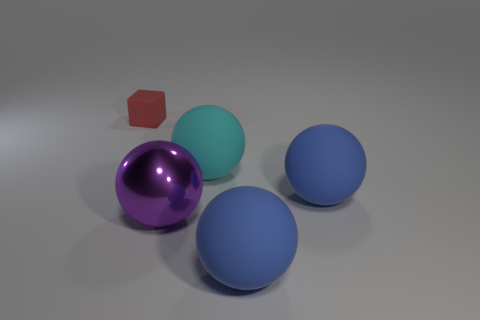Are there fewer red rubber things that are behind the large cyan matte sphere than purple metal things that are in front of the big purple shiny object?
Offer a very short reply. No. There is a thing that is both on the left side of the large cyan sphere and to the right of the red matte object; what material is it?
Give a very brief answer. Metal. There is a big metallic thing; does it have the same shape as the object behind the cyan object?
Ensure brevity in your answer.  No. How many other things are there of the same size as the red matte object?
Make the answer very short. 0. Are there more big blue metallic objects than purple spheres?
Provide a succinct answer. No. How many large spheres are on the right side of the purple object and left of the large cyan thing?
Your response must be concise. 0. What shape is the matte thing that is in front of the large blue rubber sphere behind the big ball in front of the big purple thing?
Give a very brief answer. Sphere. Is there any other thing that has the same shape as the red object?
Offer a very short reply. No. What number of cylinders are small blue metallic things or large blue rubber things?
Offer a very short reply. 0. The blue thing that is in front of the blue matte thing that is behind the large object that is left of the cyan object is made of what material?
Offer a terse response. Rubber. 